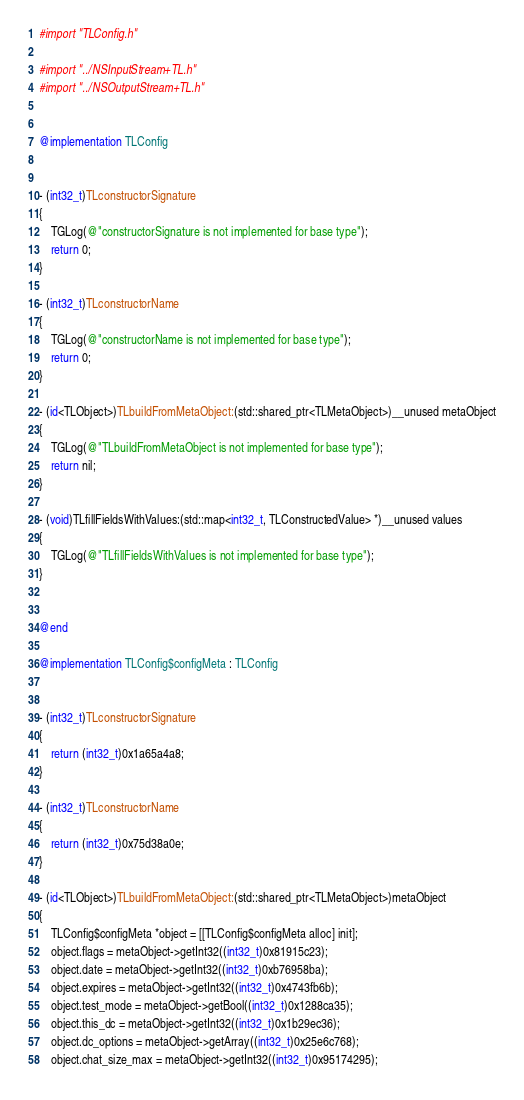Convert code to text. <code><loc_0><loc_0><loc_500><loc_500><_ObjectiveC_>#import "TLConfig.h"

#import "../NSInputStream+TL.h"
#import "../NSOutputStream+TL.h"


@implementation TLConfig


- (int32_t)TLconstructorSignature
{
    TGLog(@"constructorSignature is not implemented for base type");
    return 0;
}

- (int32_t)TLconstructorName
{
    TGLog(@"constructorName is not implemented for base type");
    return 0;
}

- (id<TLObject>)TLbuildFromMetaObject:(std::shared_ptr<TLMetaObject>)__unused metaObject
{
    TGLog(@"TLbuildFromMetaObject is not implemented for base type");
    return nil;
}

- (void)TLfillFieldsWithValues:(std::map<int32_t, TLConstructedValue> *)__unused values
{
    TGLog(@"TLfillFieldsWithValues is not implemented for base type");
}


@end

@implementation TLConfig$configMeta : TLConfig


- (int32_t)TLconstructorSignature
{
    return (int32_t)0x1a65a4a8;
}

- (int32_t)TLconstructorName
{
    return (int32_t)0x75d38a0e;
}

- (id<TLObject>)TLbuildFromMetaObject:(std::shared_ptr<TLMetaObject>)metaObject
{
    TLConfig$configMeta *object = [[TLConfig$configMeta alloc] init];
    object.flags = metaObject->getInt32((int32_t)0x81915c23);
    object.date = metaObject->getInt32((int32_t)0xb76958ba);
    object.expires = metaObject->getInt32((int32_t)0x4743fb6b);
    object.test_mode = metaObject->getBool((int32_t)0x1288ca35);
    object.this_dc = metaObject->getInt32((int32_t)0x1b29ec36);
    object.dc_options = metaObject->getArray((int32_t)0x25e6c768);
    object.chat_size_max = metaObject->getInt32((int32_t)0x95174295);</code> 